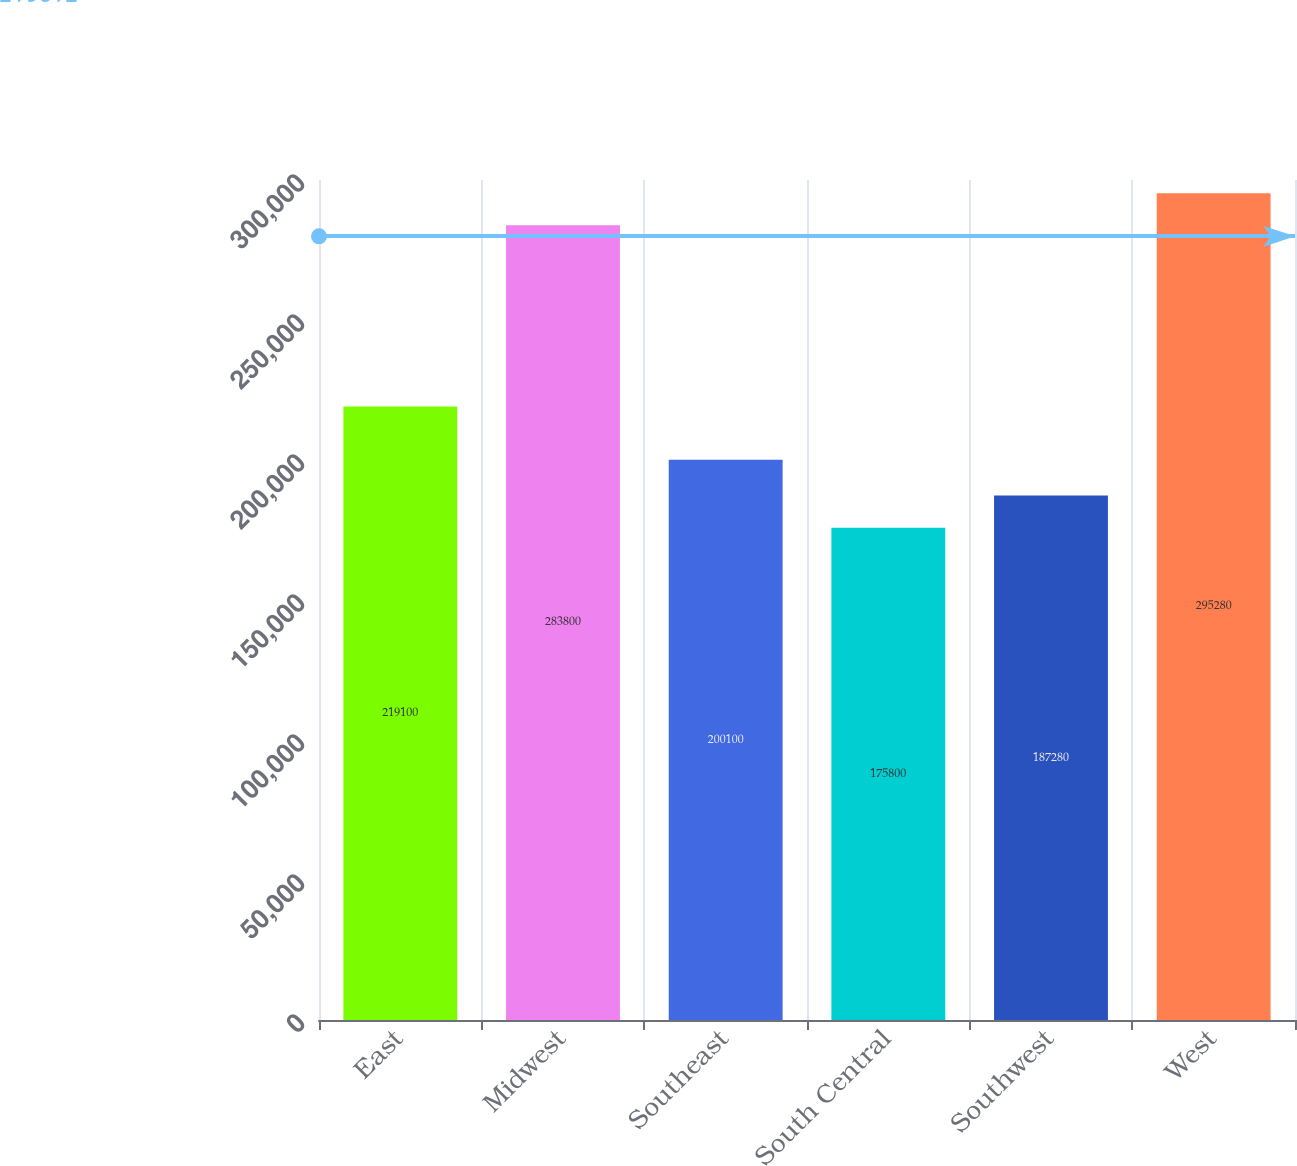Convert chart. <chart><loc_0><loc_0><loc_500><loc_500><bar_chart><fcel>East<fcel>Midwest<fcel>Southeast<fcel>South Central<fcel>Southwest<fcel>West<nl><fcel>219100<fcel>283800<fcel>200100<fcel>175800<fcel>187280<fcel>295280<nl></chart> 